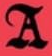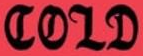What text appears in these images from left to right, separated by a semicolon? A; COLD 